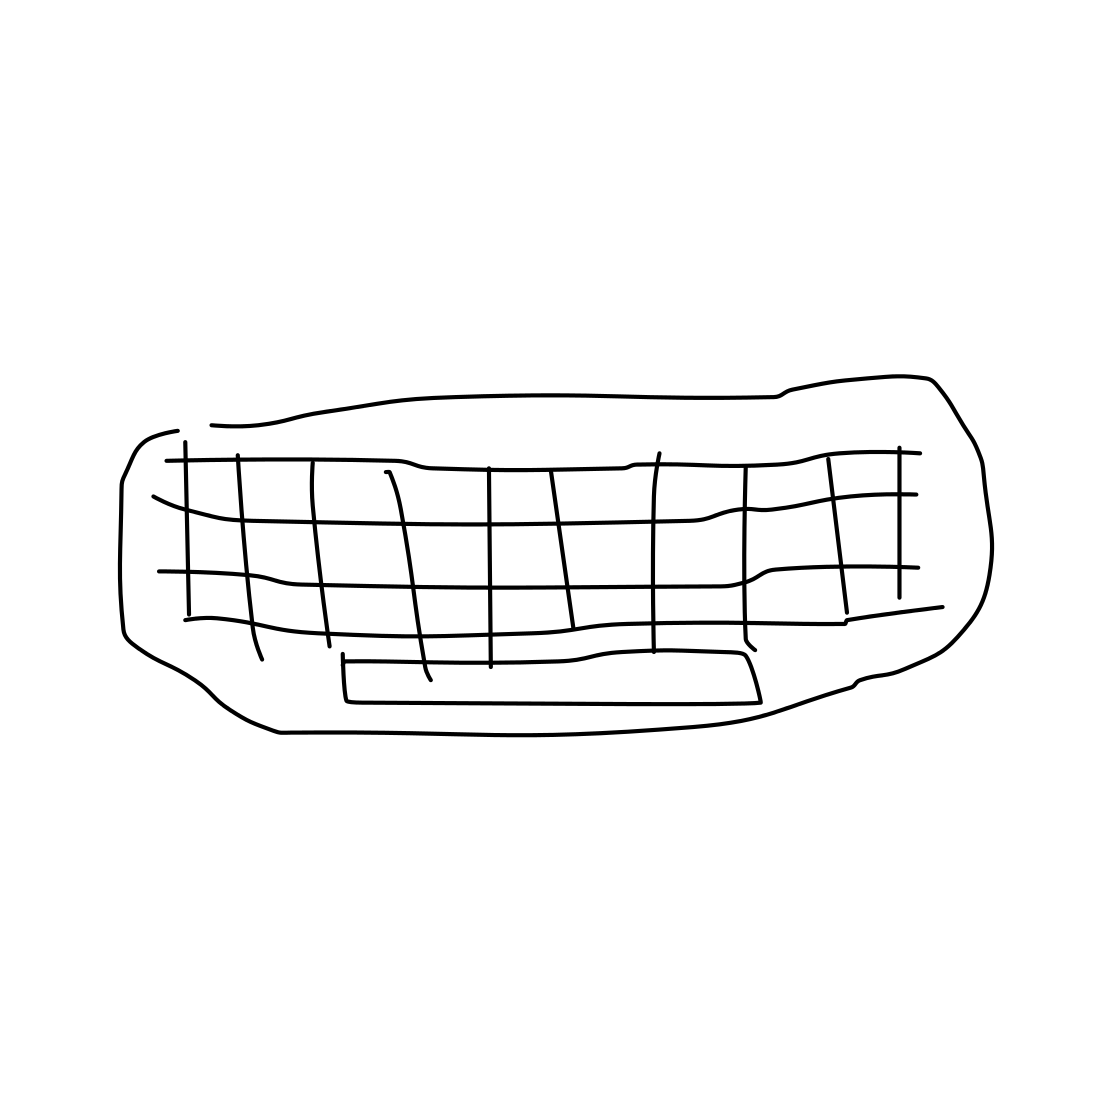What might be the purpose of using a grid pattern on the couch in this drawing? The grid pattern might be attempting to portray texture or depth, adding a sense of dimension to the otherwise flat sketch. It can also suggest that this couch might be a placeholder in a design, awaiting further refinement or customization. 